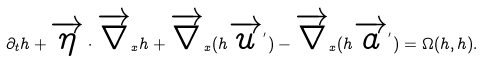Convert formula to latex. <formula><loc_0><loc_0><loc_500><loc_500>\partial _ { t } h + \overrightarrow { \eta } \cdot \overrightarrow { \nabla } _ { x } h + \overrightarrow { \nabla } _ { x } ( h \overrightarrow { u } ^ { ^ { \prime } } ) - \overrightarrow { \nabla } _ { x } ( h \overrightarrow { a } ^ { ^ { \prime } } ) = \Omega ( h , h ) .</formula> 